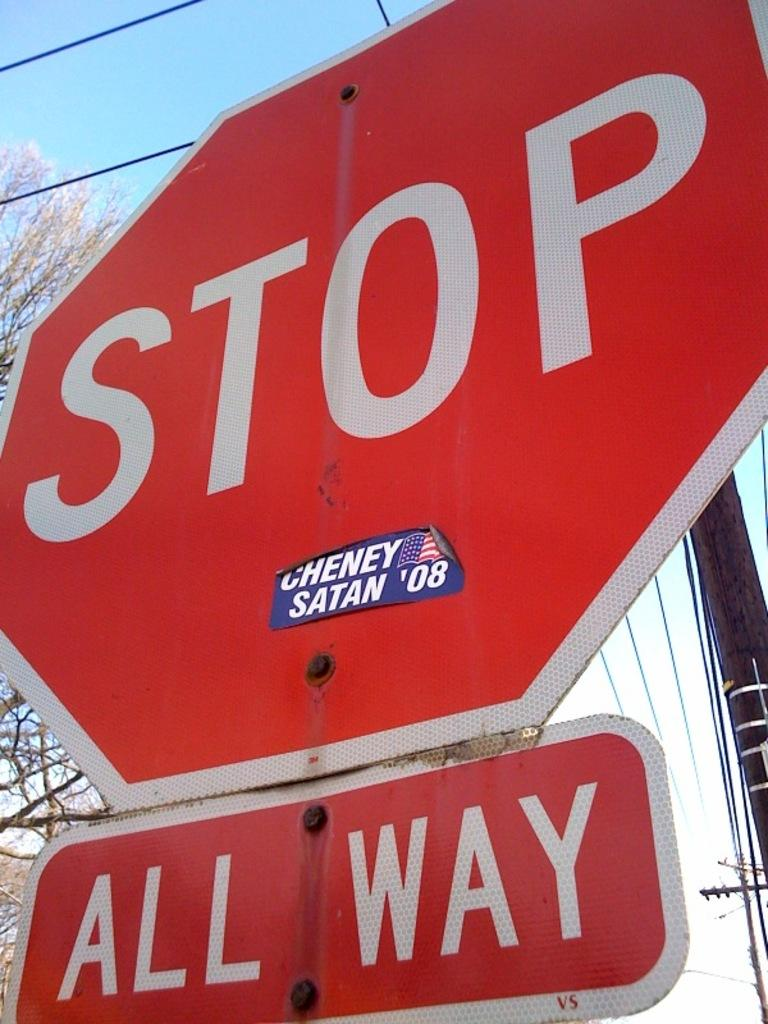<image>
Relay a brief, clear account of the picture shown. A red stop sign with another sign underneath reading 'All Way'. 